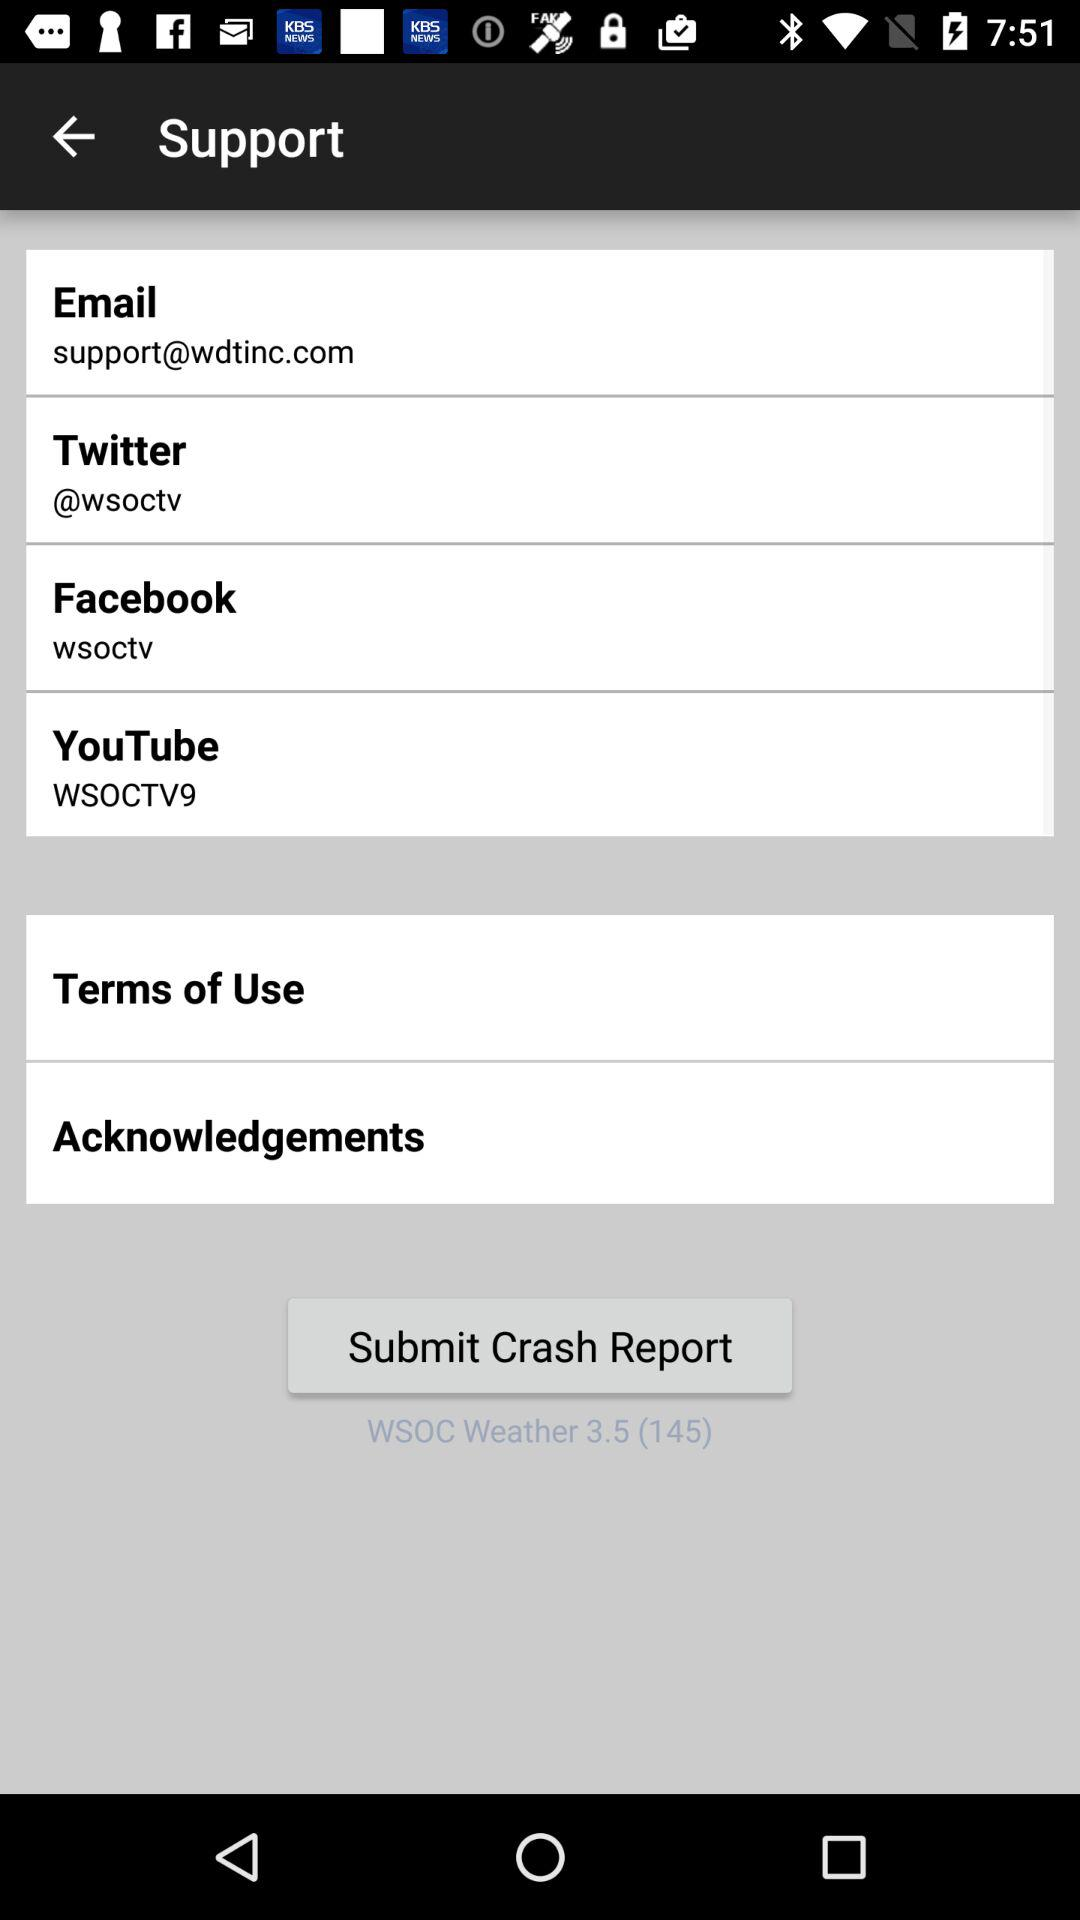What is the support "Facebook" account? The support "Facebook" account is "wsoctv". 